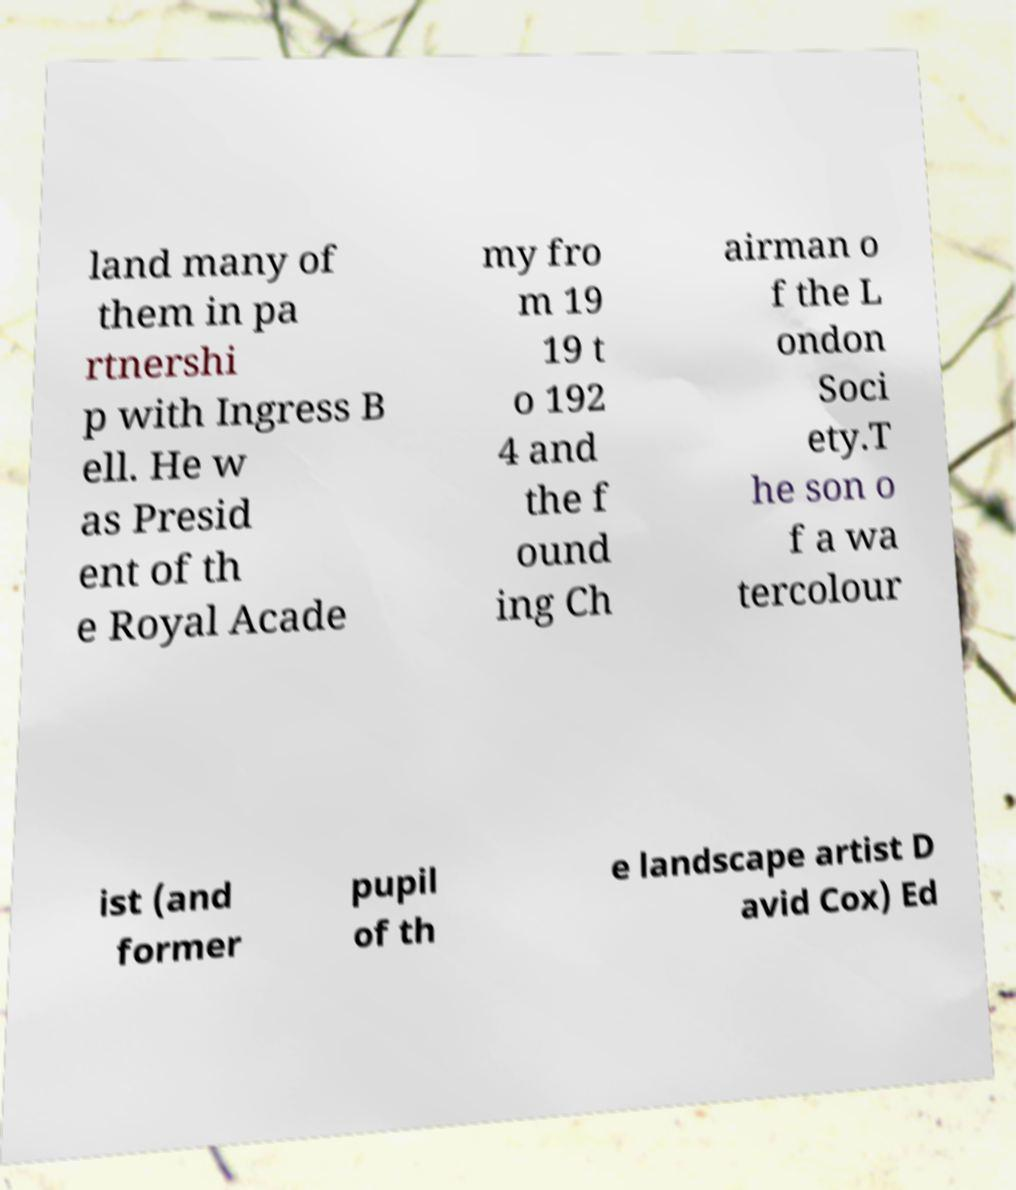Could you extract and type out the text from this image? land many of them in pa rtnershi p with Ingress B ell. He w as Presid ent of th e Royal Acade my fro m 19 19 t o 192 4 and the f ound ing Ch airman o f the L ondon Soci ety.T he son o f a wa tercolour ist (and former pupil of th e landscape artist D avid Cox) Ed 